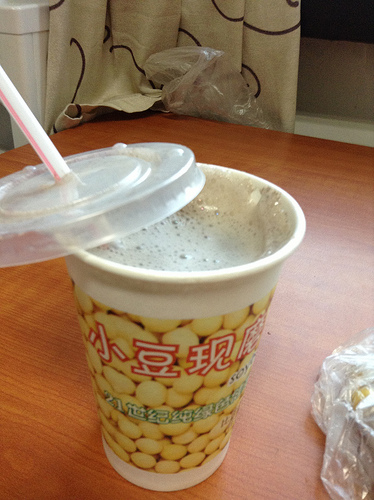<image>
Is the table in front of the straw? No. The table is not in front of the straw. The spatial positioning shows a different relationship between these objects. 